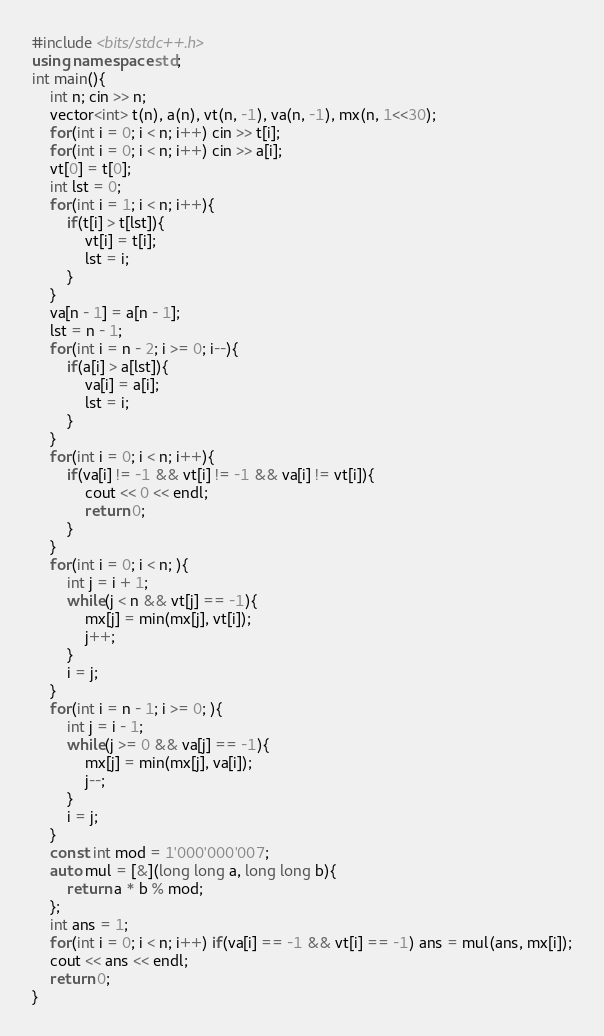<code> <loc_0><loc_0><loc_500><loc_500><_C++_>#include <bits/stdc++.h>
using namespace std;
int main(){
	int n; cin >> n;
	vector<int> t(n), a(n), vt(n, -1), va(n, -1), mx(n, 1<<30);
	for(int i = 0; i < n; i++) cin >> t[i];
	for(int i = 0; i < n; i++) cin >> a[i];
	vt[0] = t[0];
	int lst = 0;
	for(int i = 1; i < n; i++){
		if(t[i] > t[lst]){
			vt[i] = t[i];
			lst = i;
		}
	}
	va[n - 1] = a[n - 1];
	lst = n - 1;
	for(int i = n - 2; i >= 0; i--){
		if(a[i] > a[lst]){
			va[i] = a[i];
			lst = i;
		}
	}
	for(int i = 0; i < n; i++){
		if(va[i] != -1 && vt[i] != -1 && va[i] != vt[i]){
			cout << 0 << endl;
			return 0;
		}
	}
	for(int i = 0; i < n; ){
		int j = i + 1;
		while(j < n && vt[j] == -1){
			mx[j] = min(mx[j], vt[i]);
			j++;
		}
		i = j;
	}
	for(int i = n - 1; i >= 0; ){
		int j = i - 1;
		while(j >= 0 && va[j] == -1){
			mx[j] = min(mx[j], va[i]);
			j--;
		}
		i = j;
	}
	const int mod = 1'000'000'007;
	auto mul = [&](long long a, long long b){
		return a * b % mod;
	};
	int ans = 1;
	for(int i = 0; i < n; i++) if(va[i] == -1 && vt[i] == -1) ans = mul(ans, mx[i]);
	cout << ans << endl;
	return 0;
}
</code> 